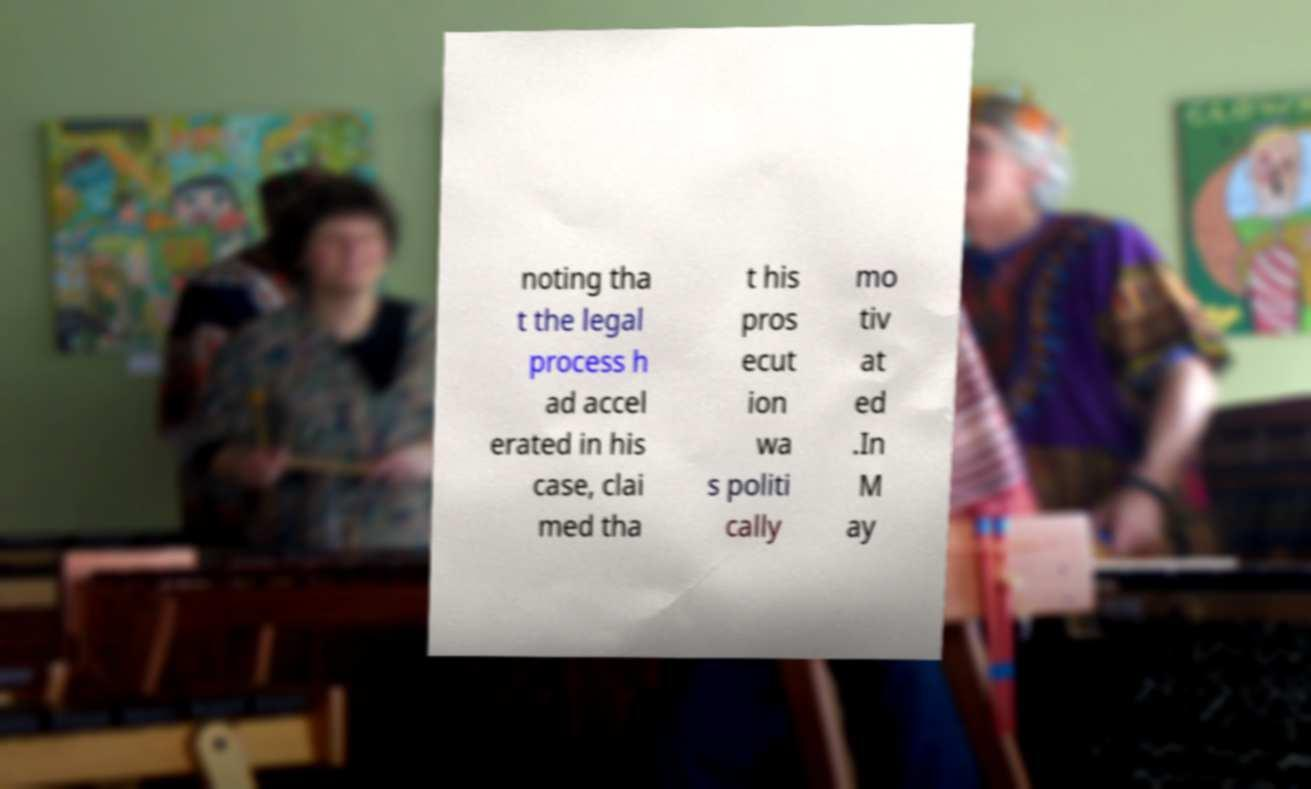Could you extract and type out the text from this image? noting tha t the legal process h ad accel erated in his case, clai med tha t his pros ecut ion wa s politi cally mo tiv at ed .In M ay 